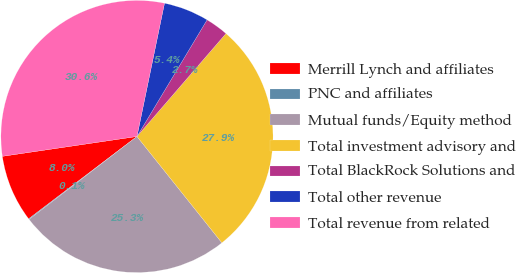<chart> <loc_0><loc_0><loc_500><loc_500><pie_chart><fcel>Merrill Lynch and affiliates<fcel>PNC and affiliates<fcel>Mutual funds/Equity method<fcel>Total investment advisory and<fcel>Total BlackRock Solutions and<fcel>Total other revenue<fcel>Total revenue from related<nl><fcel>8.01%<fcel>0.09%<fcel>25.29%<fcel>27.93%<fcel>2.73%<fcel>5.37%<fcel>30.57%<nl></chart> 